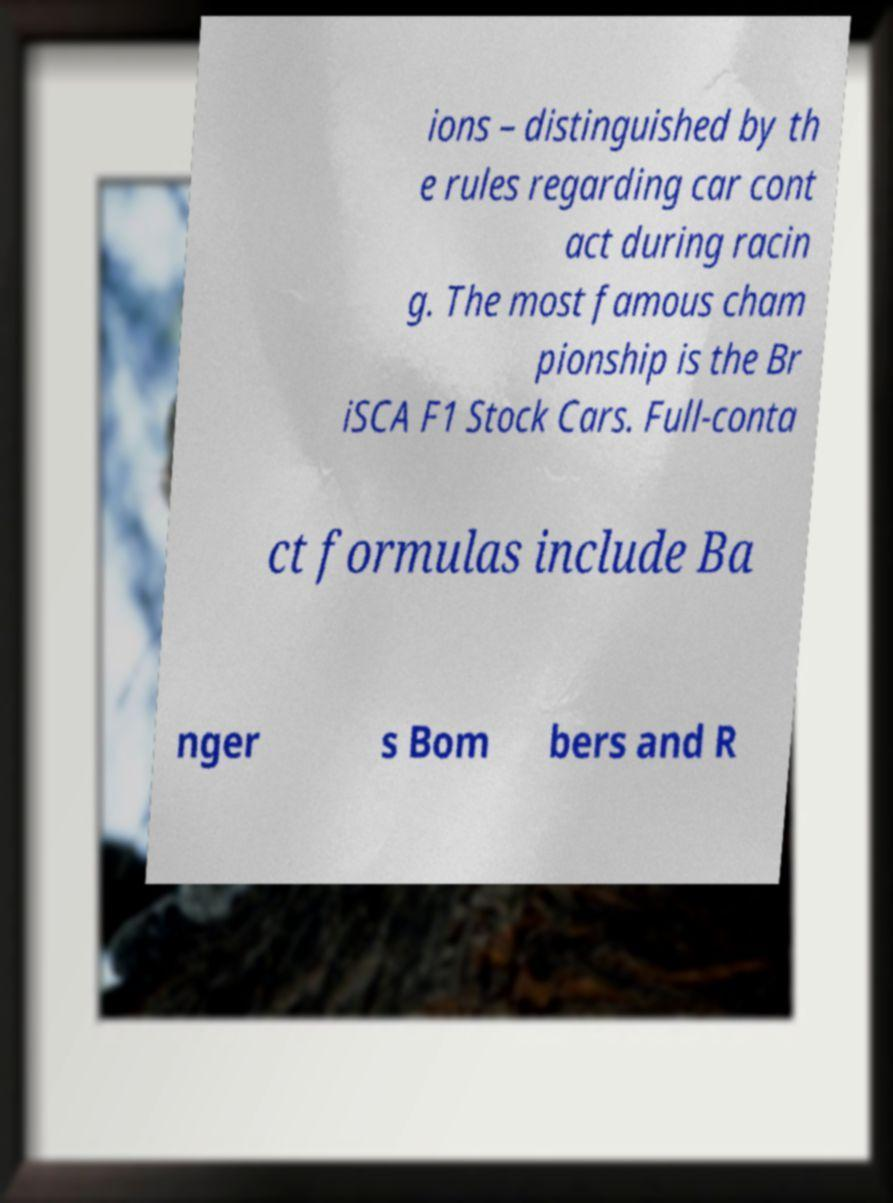Could you extract and type out the text from this image? ions – distinguished by th e rules regarding car cont act during racin g. The most famous cham pionship is the Br iSCA F1 Stock Cars. Full-conta ct formulas include Ba nger s Bom bers and R 